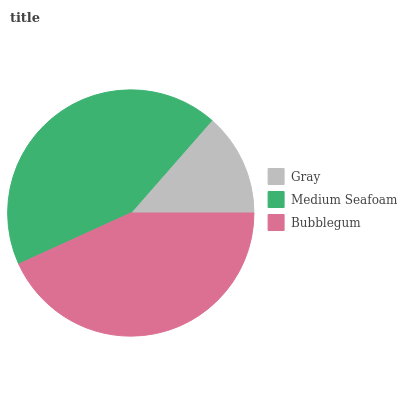Is Gray the minimum?
Answer yes or no. Yes. Is Medium Seafoam the maximum?
Answer yes or no. Yes. Is Bubblegum the minimum?
Answer yes or no. No. Is Bubblegum the maximum?
Answer yes or no. No. Is Medium Seafoam greater than Bubblegum?
Answer yes or no. Yes. Is Bubblegum less than Medium Seafoam?
Answer yes or no. Yes. Is Bubblegum greater than Medium Seafoam?
Answer yes or no. No. Is Medium Seafoam less than Bubblegum?
Answer yes or no. No. Is Bubblegum the high median?
Answer yes or no. Yes. Is Bubblegum the low median?
Answer yes or no. Yes. Is Medium Seafoam the high median?
Answer yes or no. No. Is Medium Seafoam the low median?
Answer yes or no. No. 